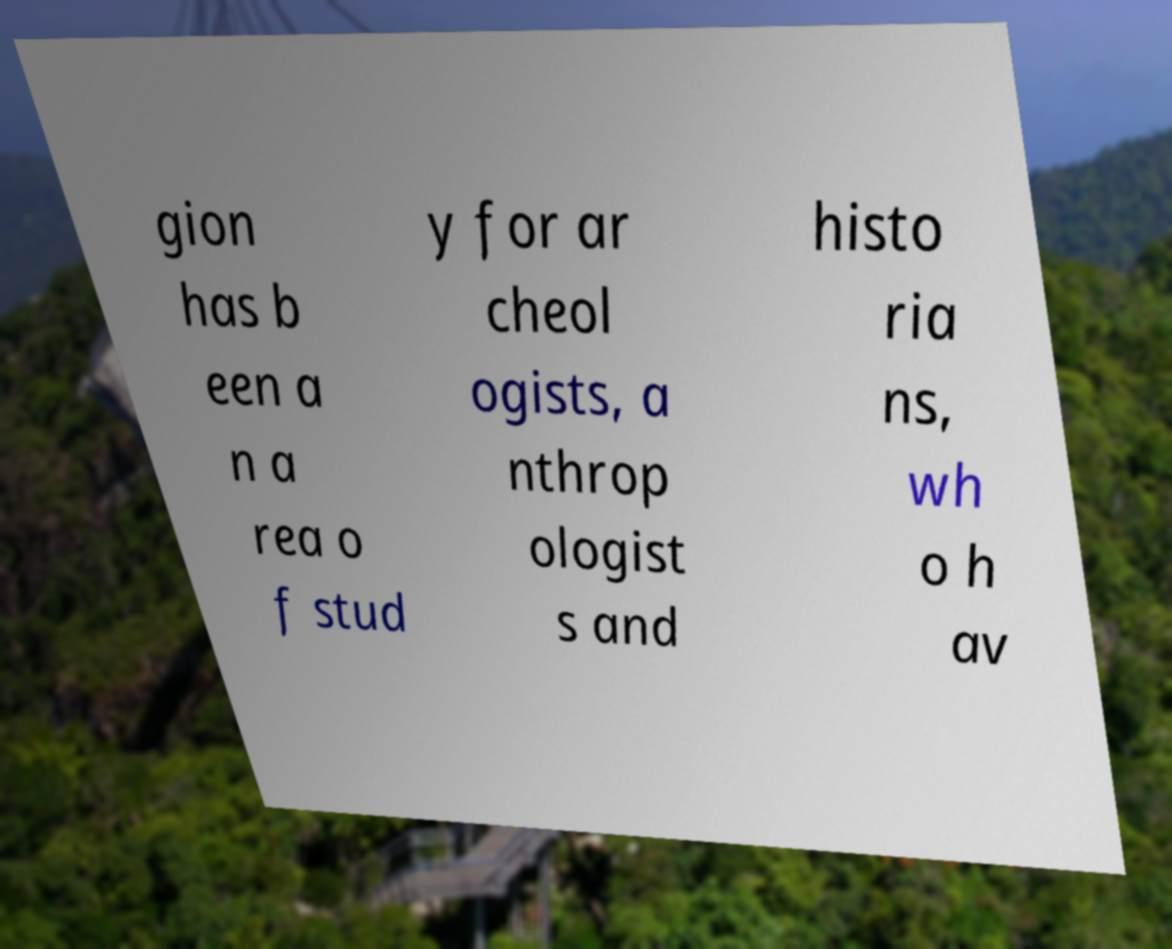There's text embedded in this image that I need extracted. Can you transcribe it verbatim? gion has b een a n a rea o f stud y for ar cheol ogists, a nthrop ologist s and histo ria ns, wh o h av 